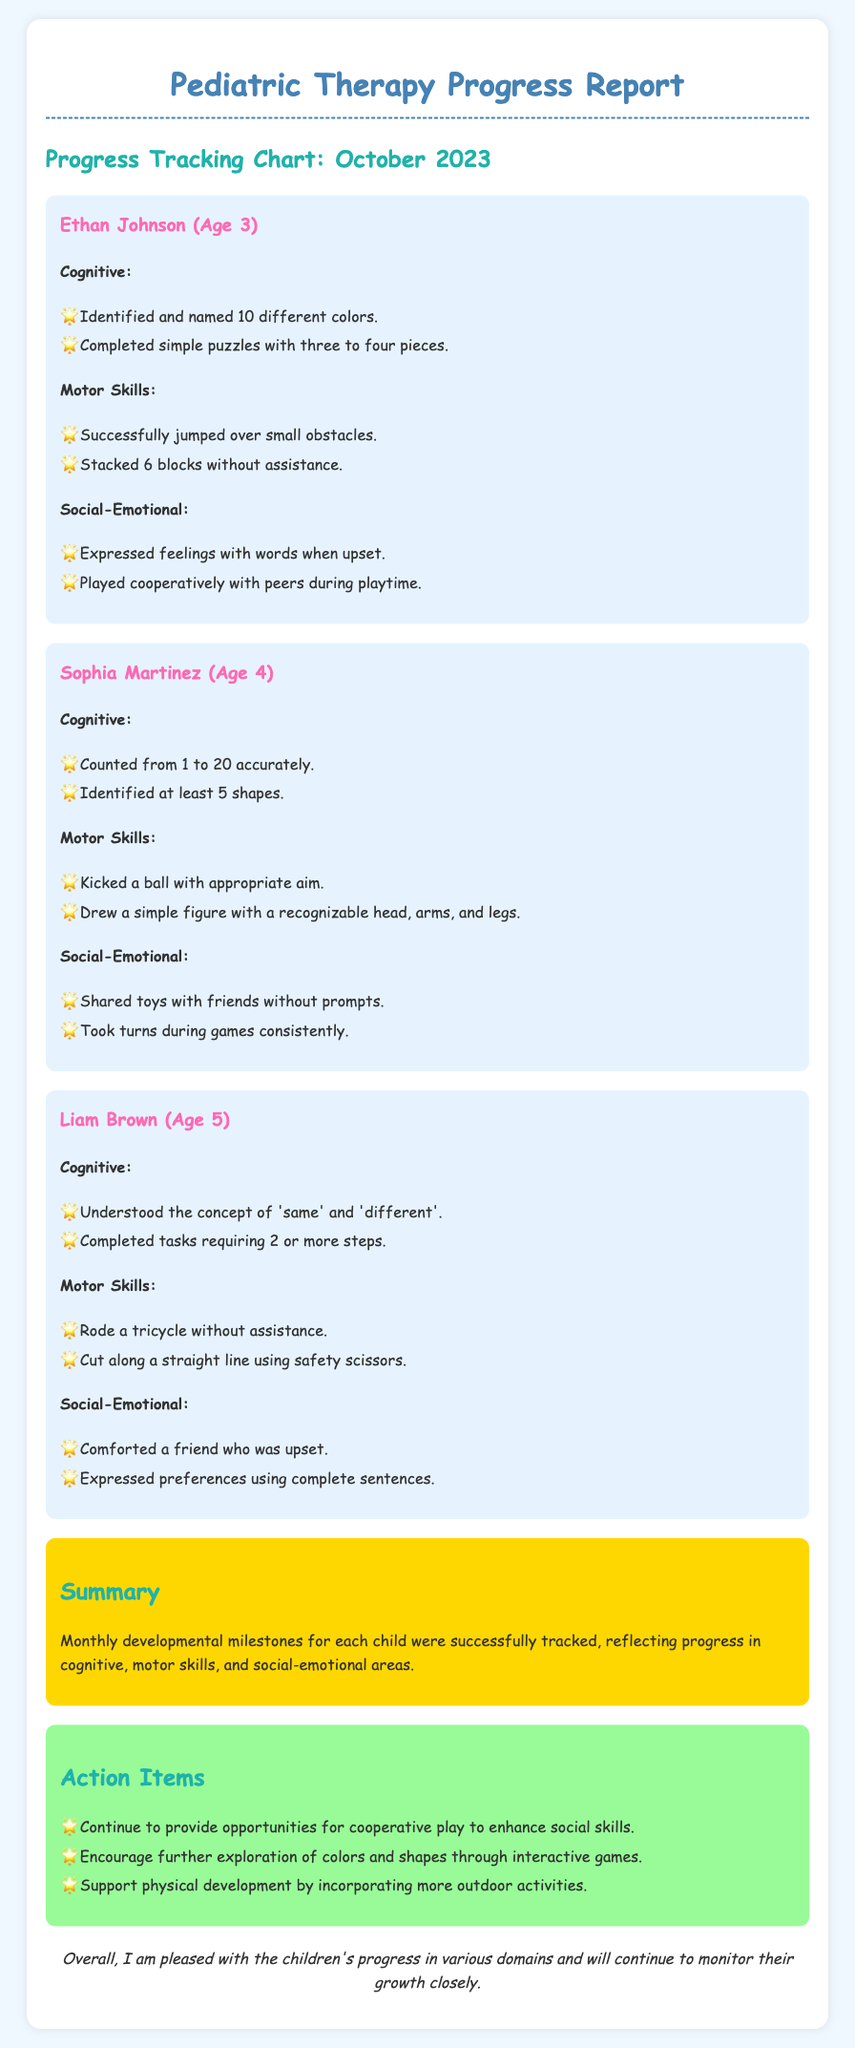What is the name of the first child? The first child's name is provided in the document as Ethan Johnson.
Answer: Ethan Johnson How old is Sophia Martinez? The document states that Sophia Martinez is 4 years old.
Answer: 4 What developmental milestone did Liam Brown achieve in Motor Skills? The document lists that Liam Brown rode a tricycle without assistance as a motor skill milestone.
Answer: Rode a tricycle without assistance How many colors did Ethan Johnson identify? According to the document, Ethan Johnson identified and named 10 different colors.
Answer: 10 What is the main goal of the action items? The action items aim to provide guidance on supporting children's development through cooperative play and outdoor activities.
Answer: Supporting development Which age group does the cognitive milestone of counting from 1 to 20 belong to? The cognitive milestone of counting from 1 to 20 is attributed to Sophia Martinez, who is 4 years old.
Answer: 4 years old What type of report is this document? The document is categorized as a Pediatric Therapy Progress Report.
Answer: Pediatric Therapy Progress Report What milestone reflects social-emotional development for Ethan Johnson? The document indicates Ethan expressed feelings with words when upset as a milestone in social-emotional development.
Answer: Expressed feelings with words when upset What action item suggests enhancing social skills? The document states to continue providing opportunities for cooperative play to enhance social skills as an action item.
Answer: Cooperative play 